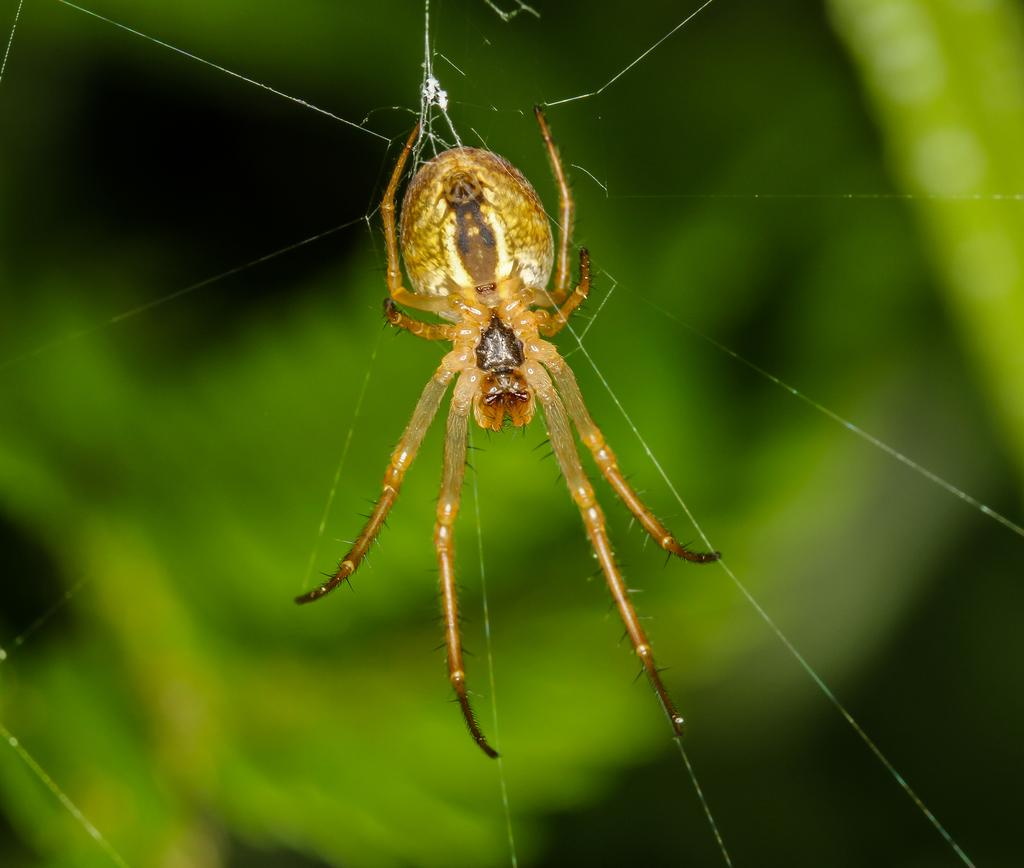Where was the image taken? The image was taken outdoors. What can be observed in the background of the image? The background of the image is blurred and green in color. What is the main subject of the image? There is a spider in the middle of the image. Are there any additional features related to the spider in the image? Yes, there is a spider web in the image. What type of jewel is the man wearing in the image? There is no man present in the image, and therefore no one is wearing any jewelry. Can you tell me how many sinks are visible in the image? There are no sinks present in the image. 